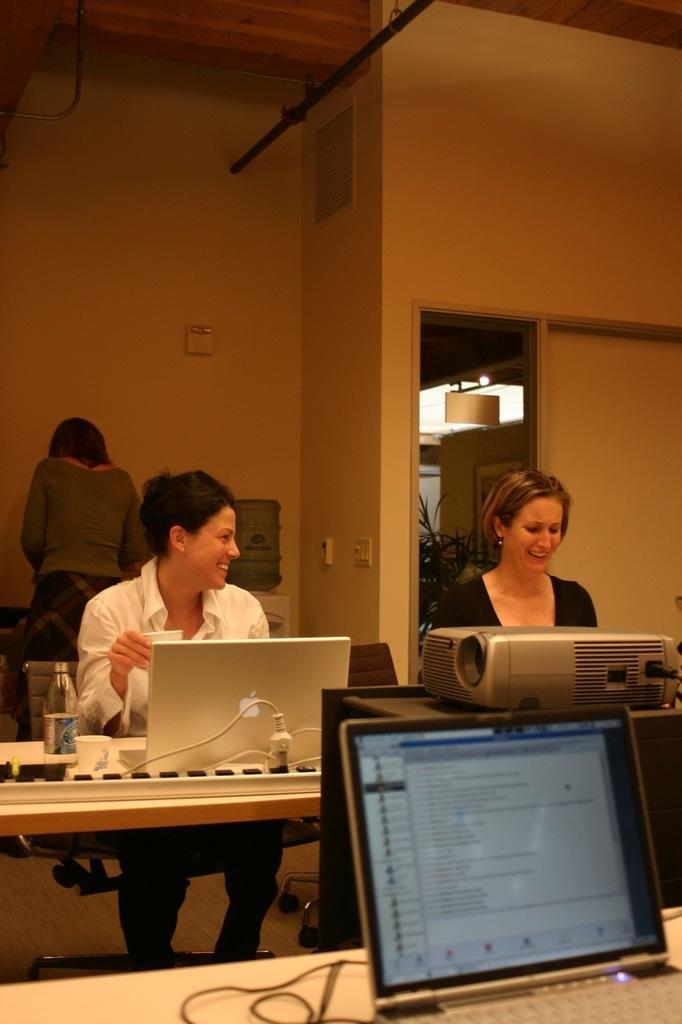Could you give a brief overview of what you see in this image? In this picture we can see two persons sitting on chair and in front of them there is table and on table we can see bottle, cup, laptop, wires , machine and in background we can see woman standing, wall, light, plant. 